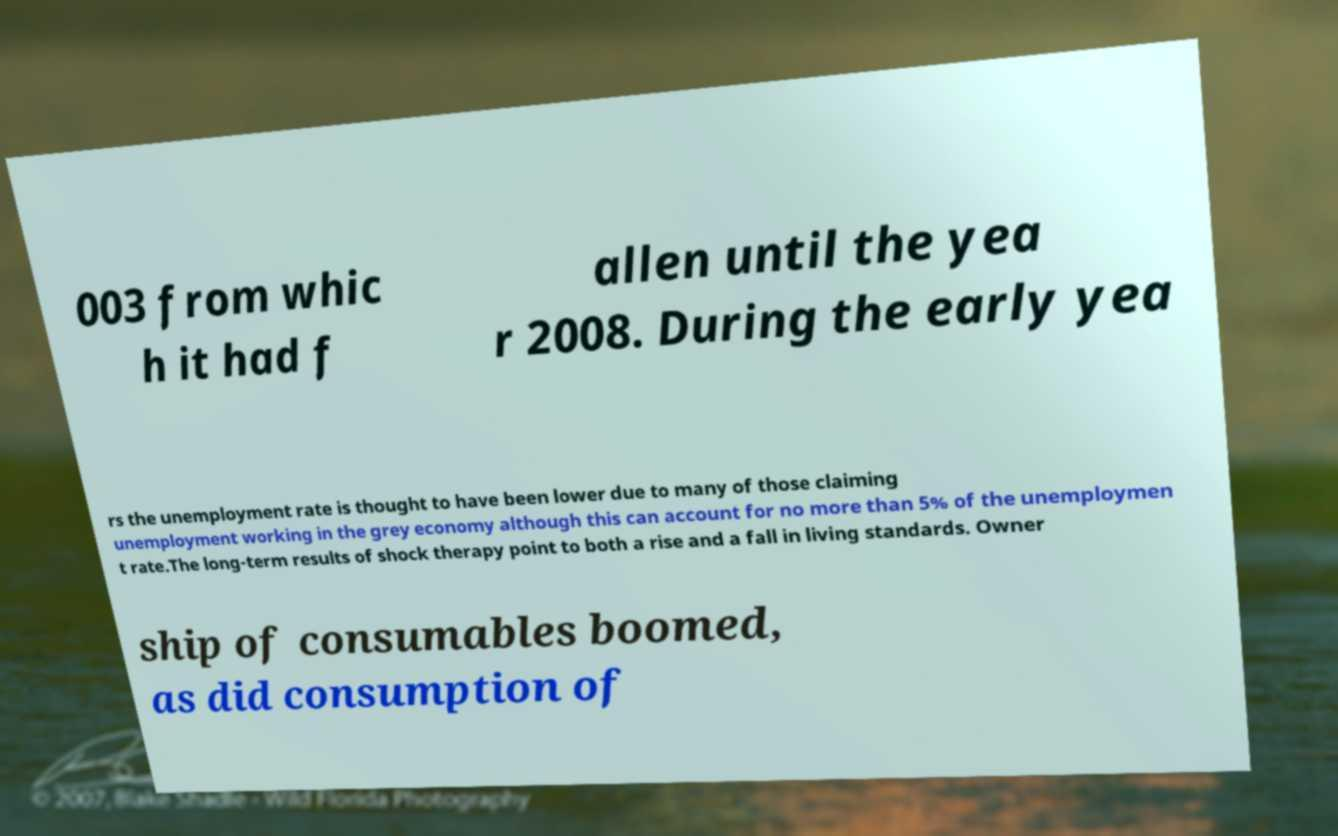There's text embedded in this image that I need extracted. Can you transcribe it verbatim? 003 from whic h it had f allen until the yea r 2008. During the early yea rs the unemployment rate is thought to have been lower due to many of those claiming unemployment working in the grey economy although this can account for no more than 5% of the unemploymen t rate.The long-term results of shock therapy point to both a rise and a fall in living standards. Owner ship of consumables boomed, as did consumption of 